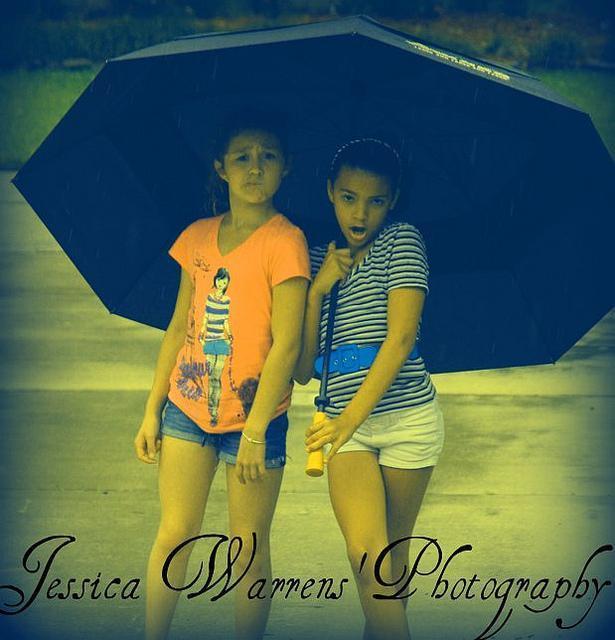How many people are there?
Give a very brief answer. 2. 